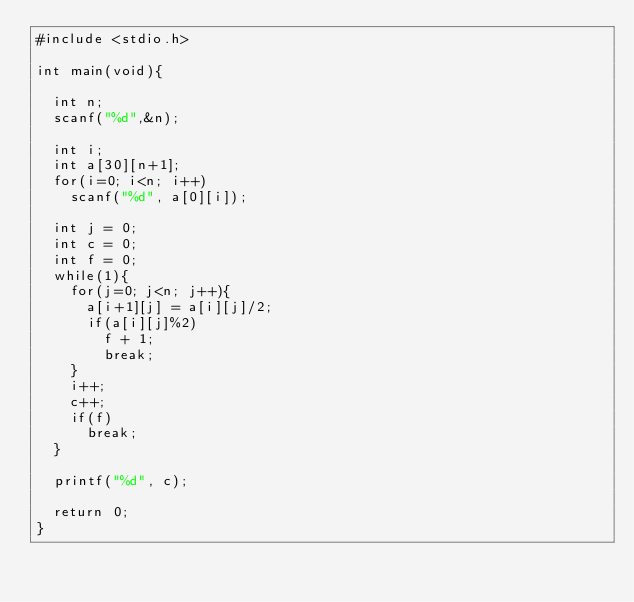Convert code to text. <code><loc_0><loc_0><loc_500><loc_500><_C_>#include <stdio.h>

int main(void){
  
  int n;
  scanf("%d",&n);
  
  int i;
  int a[30][n+1];
  for(i=0; i<n; i++)
    scanf("%d", a[0][i]);
  
  int j = 0;
  int c = 0;
  int f = 0;
  while(1){
    for(j=0; j<n; j++){
      a[i+1][j] = a[i][j]/2;
      if(a[i][j]%2)
        f + 1;
        break;
    }
    i++;
    c++;
    if(f)
      break;
  }
  
  printf("%d", c);
  
  return 0;
}
</code> 